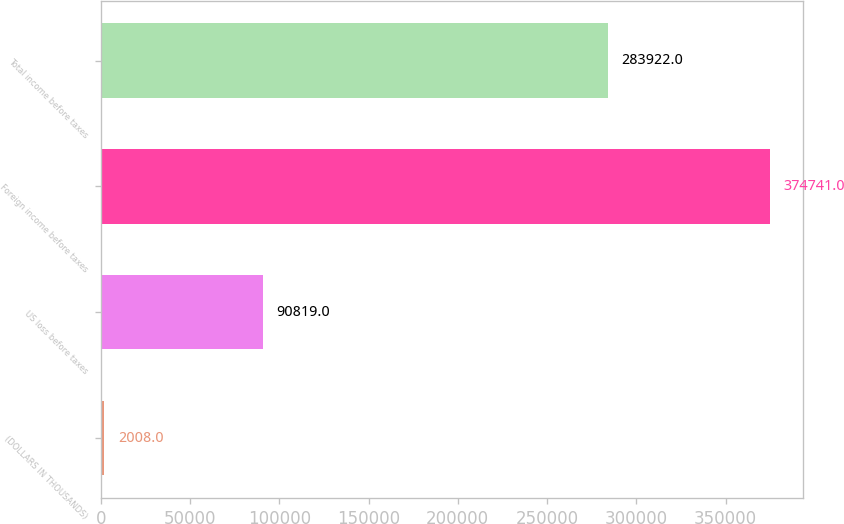<chart> <loc_0><loc_0><loc_500><loc_500><bar_chart><fcel>(DOLLARS IN THOUSANDS)<fcel>US loss before taxes<fcel>Foreign income before taxes<fcel>Total income before taxes<nl><fcel>2008<fcel>90819<fcel>374741<fcel>283922<nl></chart> 